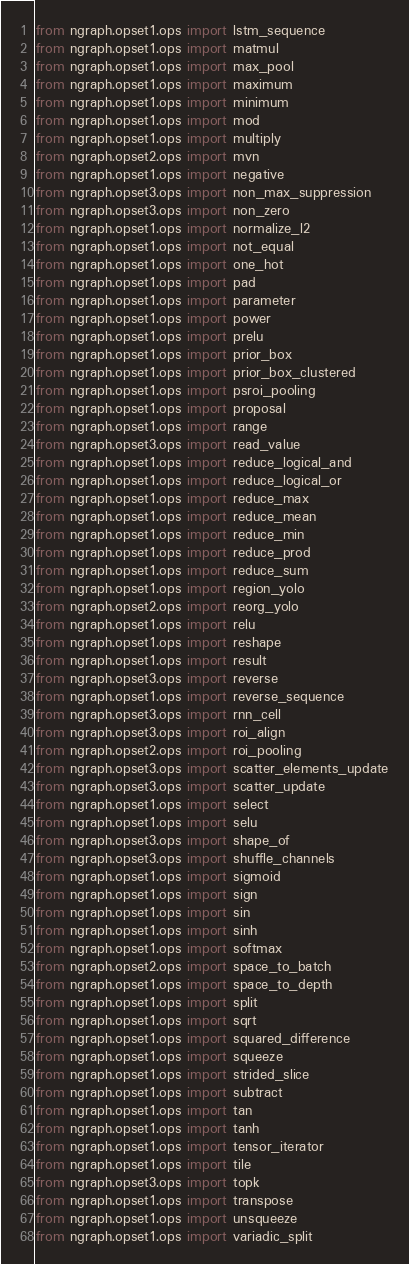<code> <loc_0><loc_0><loc_500><loc_500><_Python_>from ngraph.opset1.ops import lstm_sequence
from ngraph.opset1.ops import matmul
from ngraph.opset1.ops import max_pool
from ngraph.opset1.ops import maximum
from ngraph.opset1.ops import minimum
from ngraph.opset1.ops import mod
from ngraph.opset1.ops import multiply
from ngraph.opset2.ops import mvn
from ngraph.opset1.ops import negative
from ngraph.opset3.ops import non_max_suppression
from ngraph.opset3.ops import non_zero
from ngraph.opset1.ops import normalize_l2
from ngraph.opset1.ops import not_equal
from ngraph.opset1.ops import one_hot
from ngraph.opset1.ops import pad
from ngraph.opset1.ops import parameter
from ngraph.opset1.ops import power
from ngraph.opset1.ops import prelu
from ngraph.opset1.ops import prior_box
from ngraph.opset1.ops import prior_box_clustered
from ngraph.opset1.ops import psroi_pooling
from ngraph.opset1.ops import proposal
from ngraph.opset1.ops import range
from ngraph.opset3.ops import read_value
from ngraph.opset1.ops import reduce_logical_and
from ngraph.opset1.ops import reduce_logical_or
from ngraph.opset1.ops import reduce_max
from ngraph.opset1.ops import reduce_mean
from ngraph.opset1.ops import reduce_min
from ngraph.opset1.ops import reduce_prod
from ngraph.opset1.ops import reduce_sum
from ngraph.opset1.ops import region_yolo
from ngraph.opset2.ops import reorg_yolo
from ngraph.opset1.ops import relu
from ngraph.opset1.ops import reshape
from ngraph.opset1.ops import result
from ngraph.opset3.ops import reverse
from ngraph.opset1.ops import reverse_sequence
from ngraph.opset3.ops import rnn_cell
from ngraph.opset3.ops import roi_align
from ngraph.opset2.ops import roi_pooling
from ngraph.opset3.ops import scatter_elements_update
from ngraph.opset3.ops import scatter_update
from ngraph.opset1.ops import select
from ngraph.opset1.ops import selu
from ngraph.opset3.ops import shape_of
from ngraph.opset3.ops import shuffle_channels
from ngraph.opset1.ops import sigmoid
from ngraph.opset1.ops import sign
from ngraph.opset1.ops import sin
from ngraph.opset1.ops import sinh
from ngraph.opset1.ops import softmax
from ngraph.opset2.ops import space_to_batch
from ngraph.opset1.ops import space_to_depth
from ngraph.opset1.ops import split
from ngraph.opset1.ops import sqrt
from ngraph.opset1.ops import squared_difference
from ngraph.opset1.ops import squeeze
from ngraph.opset1.ops import strided_slice
from ngraph.opset1.ops import subtract
from ngraph.opset1.ops import tan
from ngraph.opset1.ops import tanh
from ngraph.opset1.ops import tensor_iterator
from ngraph.opset1.ops import tile
from ngraph.opset3.ops import topk
from ngraph.opset1.ops import transpose
from ngraph.opset1.ops import unsqueeze
from ngraph.opset1.ops import variadic_split
</code> 